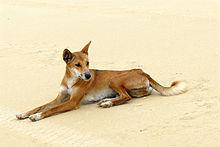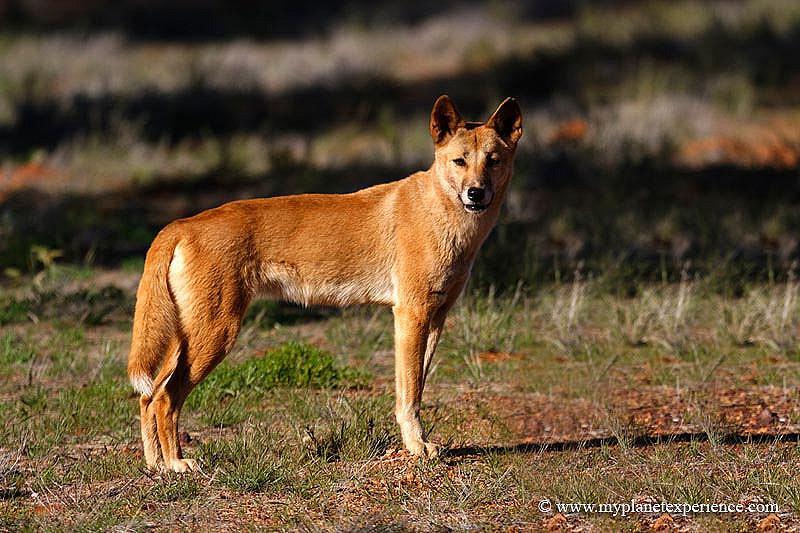The first image is the image on the left, the second image is the image on the right. Considering the images on both sides, is "In the right image, one canine is lying on the grass." valid? Answer yes or no. No. The first image is the image on the left, the second image is the image on the right. For the images displayed, is the sentence "the animal in the image on the left is standing on all fours." factually correct? Answer yes or no. No. 